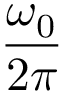Convert formula to latex. <formula><loc_0><loc_0><loc_500><loc_500>\frac { \omega _ { 0 } } { 2 \pi }</formula> 